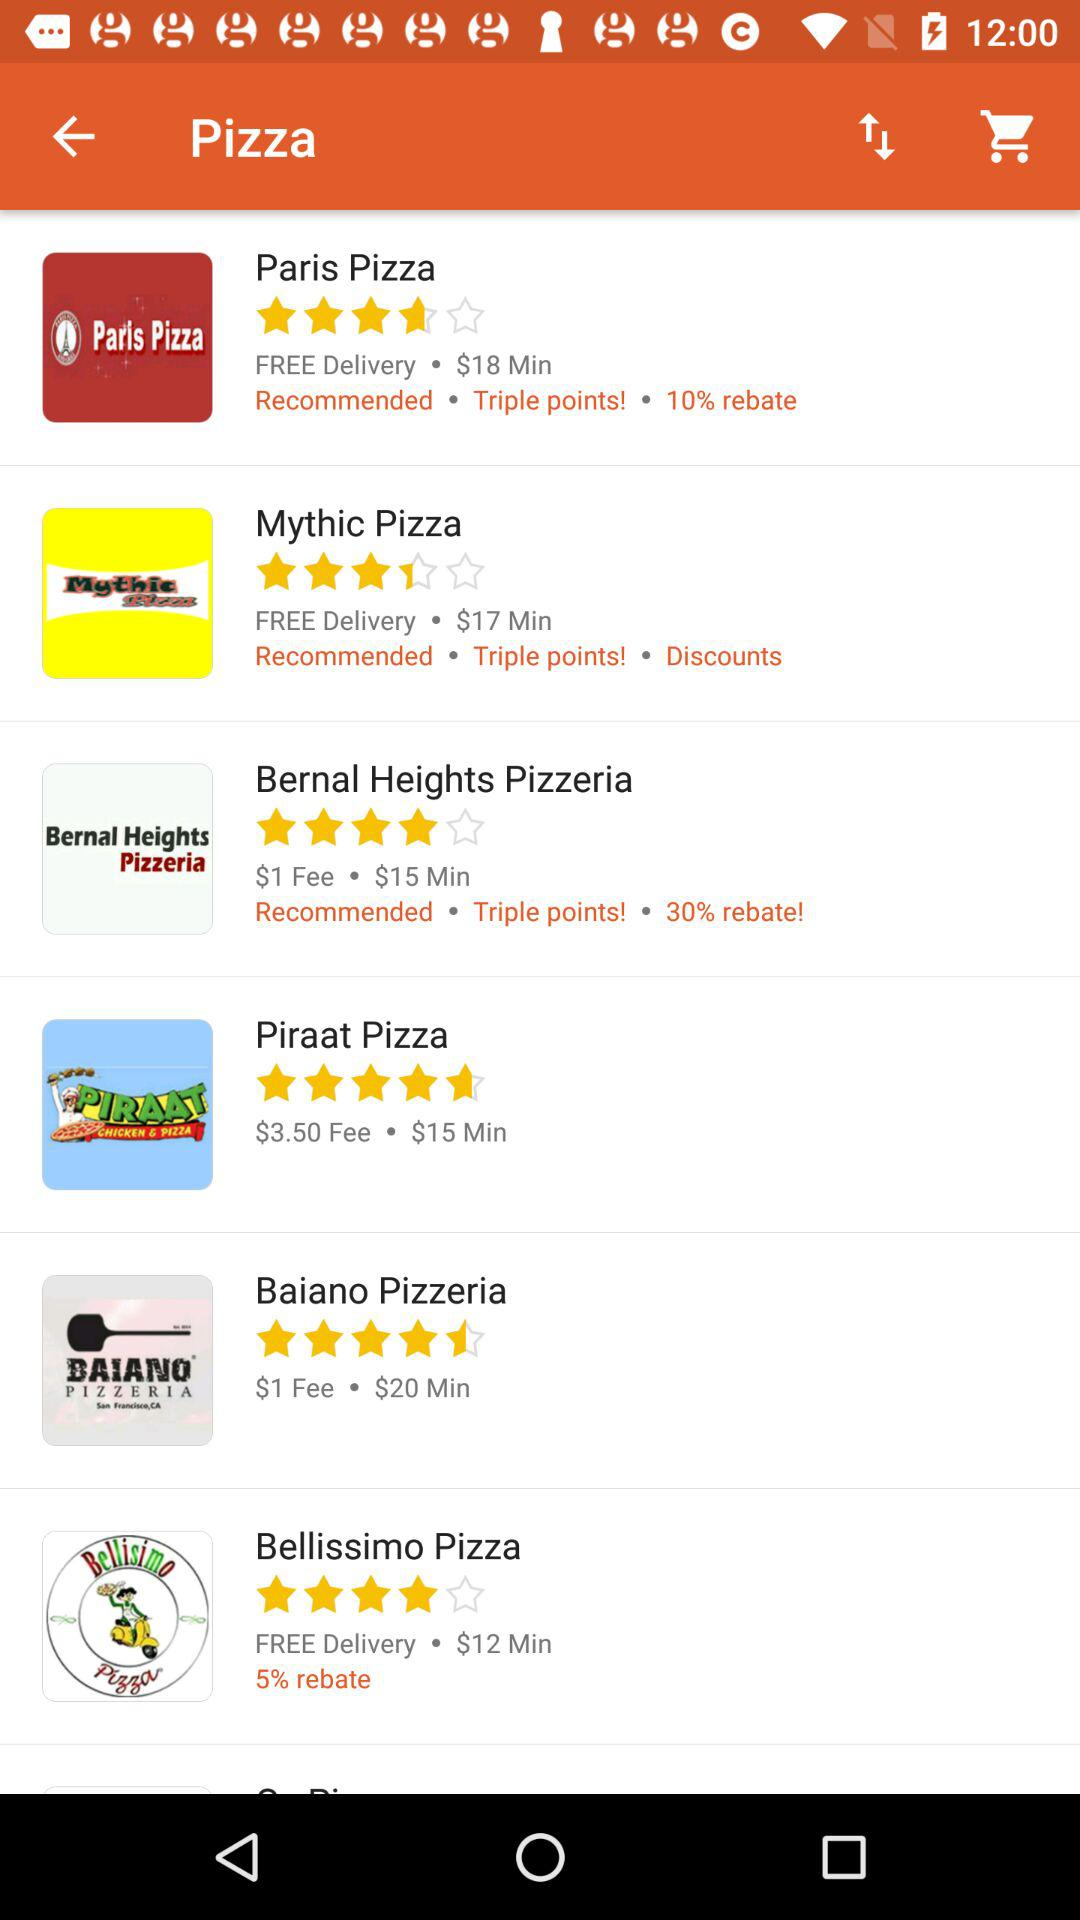How many stars does the Bernal Heights Pizzeria get? The Bernal Heights Pizzeria gets 4 stars. 